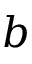Convert formula to latex. <formula><loc_0><loc_0><loc_500><loc_500>b</formula> 